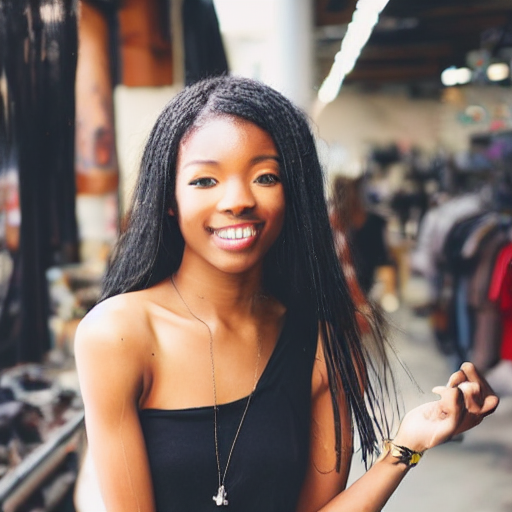What might the subject's attire and accessories suggest about her? Her attire, which includes a simple black tank top accessorized with a delicate necklace and a wristband, suggests a sense of modern, relaxed fashion. The minimalistic style may indicate a preference for comfort and a certain laid-back, yet polished personal aesthetic. 